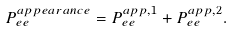Convert formula to latex. <formula><loc_0><loc_0><loc_500><loc_500>P _ { e e } ^ { a p p e a r a n c e } = P _ { e e } ^ { a p p , 1 } + P _ { e e } ^ { a p p , 2 } .</formula> 